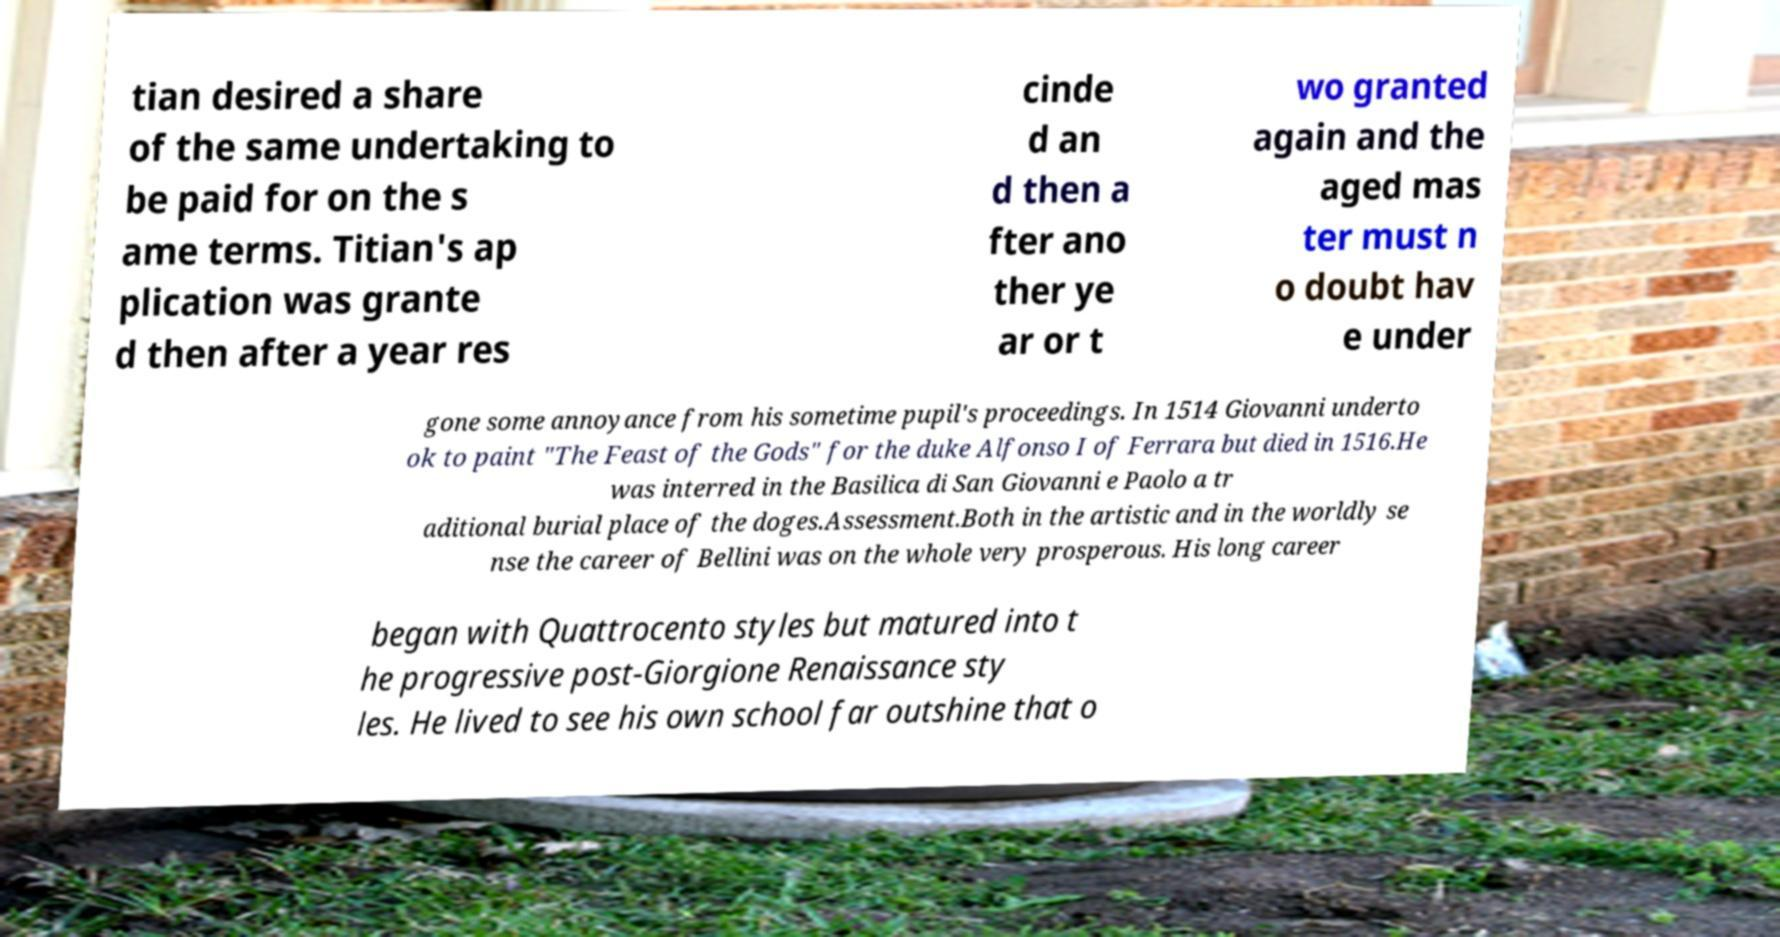There's text embedded in this image that I need extracted. Can you transcribe it verbatim? tian desired a share of the same undertaking to be paid for on the s ame terms. Titian's ap plication was grante d then after a year res cinde d an d then a fter ano ther ye ar or t wo granted again and the aged mas ter must n o doubt hav e under gone some annoyance from his sometime pupil's proceedings. In 1514 Giovanni underto ok to paint "The Feast of the Gods" for the duke Alfonso I of Ferrara but died in 1516.He was interred in the Basilica di San Giovanni e Paolo a tr aditional burial place of the doges.Assessment.Both in the artistic and in the worldly se nse the career of Bellini was on the whole very prosperous. His long career began with Quattrocento styles but matured into t he progressive post-Giorgione Renaissance sty les. He lived to see his own school far outshine that o 